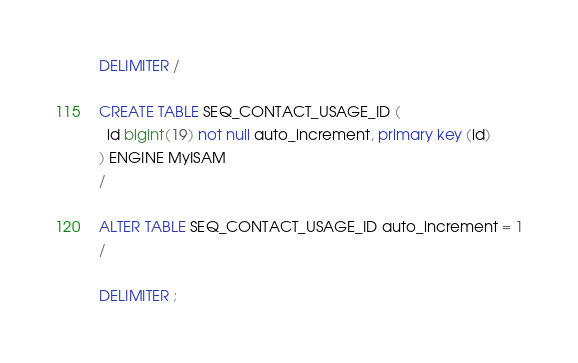<code> <loc_0><loc_0><loc_500><loc_500><_SQL_>DELIMITER /

CREATE TABLE SEQ_CONTACT_USAGE_ID (
  id bigint(19) not null auto_increment, primary key (id)
) ENGINE MyISAM
/

ALTER TABLE SEQ_CONTACT_USAGE_ID auto_increment = 1
/

DELIMITER ;
</code> 